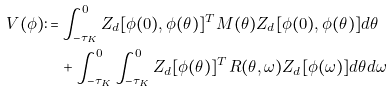<formula> <loc_0><loc_0><loc_500><loc_500>V ( \phi ) \colon = & \int _ { - \tau _ { K } } ^ { 0 } Z _ { d } [ \phi ( 0 ) , \phi ( \theta ) ] ^ { T } M ( \theta ) Z _ { d } [ \phi ( 0 ) , \phi ( \theta ) ] d \theta \\ & + \int _ { - \tau _ { K } } ^ { 0 } \int _ { - \tau _ { K } } ^ { 0 } Z _ { d } [ \phi ( \theta ) ] ^ { T } R ( \theta , \omega ) Z _ { d } [ \phi ( \omega ) ] d \theta d \omega</formula> 